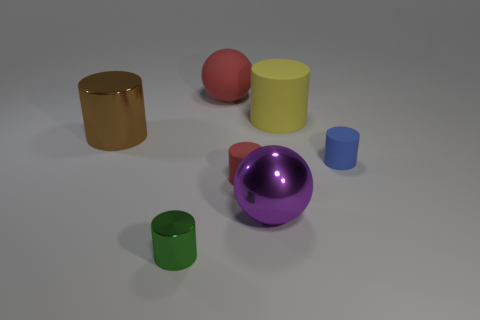There is a large cylinder left of the large cylinder right of the metal cylinder that is right of the big brown thing; what color is it?
Provide a succinct answer. Brown. How many other objects are the same color as the large rubber cylinder?
Your answer should be compact. 0. Are there fewer red matte objects than matte objects?
Offer a terse response. Yes. There is a big object that is both on the left side of the big yellow object and behind the large brown metallic thing; what is its color?
Keep it short and to the point. Red. There is a brown thing that is the same shape as the small green metallic thing; what is it made of?
Your response must be concise. Metal. Is the number of spheres greater than the number of green cylinders?
Keep it short and to the point. Yes. There is a object that is behind the big shiny cylinder and in front of the large red ball; how big is it?
Make the answer very short. Large. The purple object is what shape?
Provide a succinct answer. Sphere. What number of other big red things have the same shape as the large red matte object?
Keep it short and to the point. 0. Are there fewer big matte things in front of the big rubber ball than red rubber cylinders that are in front of the big purple thing?
Offer a very short reply. No. 